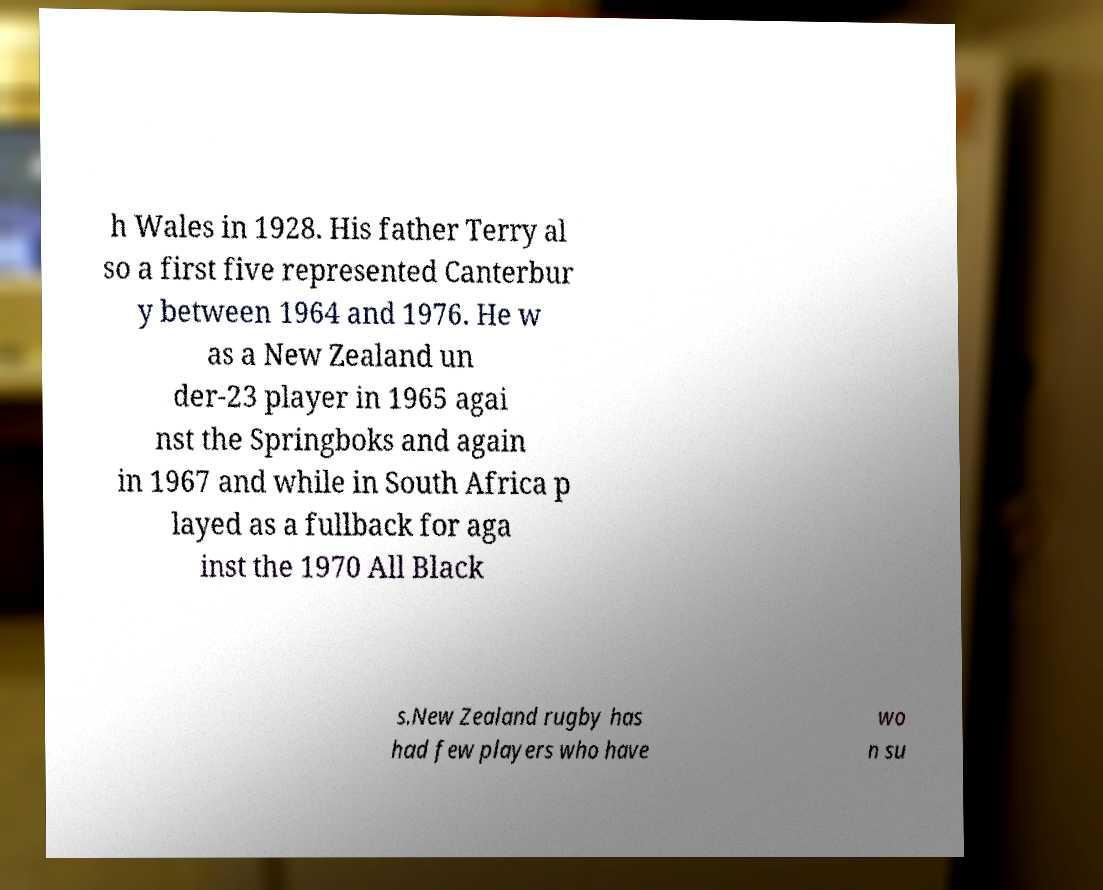Can you read and provide the text displayed in the image?This photo seems to have some interesting text. Can you extract and type it out for me? h Wales in 1928. His father Terry al so a first five represented Canterbur y between 1964 and 1976. He w as a New Zealand un der-23 player in 1965 agai nst the Springboks and again in 1967 and while in South Africa p layed as a fullback for aga inst the 1970 All Black s.New Zealand rugby has had few players who have wo n su 